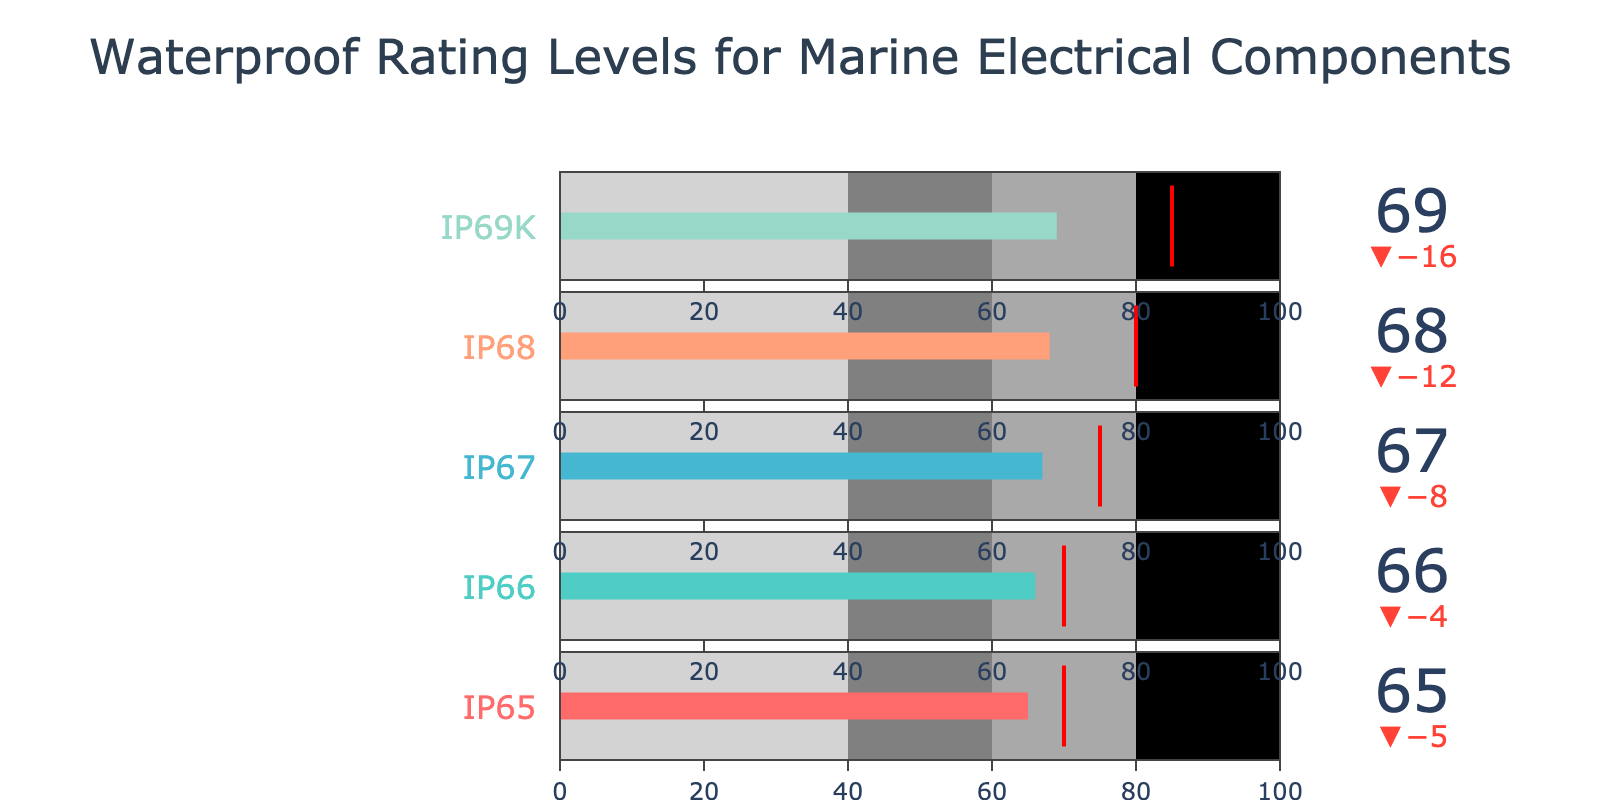What's the title of the figure? The title of the figure is displayed at the top and generally gives an overview of what the visualization is about. Read the text located prominently at the top of the figure.
Answer: Waterproof Rating Levels for Marine Electrical Components How many data points are plotted in the figure? Each bullet chart row represents a data point. You can count the number of different waterproof rating levels provided.
Answer: 5 What is the actual waterproof rating for IP68? Look for the IP68 row and identify the 'Actual' value associated with it.
Answer: 68 Which component has the highest comparative waterproof rating? Compare all 'Comparative' values across the rows and identify the highest value, then see which component it corresponds to.
Answer: IP69K Is the actual waterproof rating for any component below 60? Check the 'Actual' values across all rows to see if any are below 60.
Answer: No Which component has the smallest difference between actual and comparative waterproof ratings? Calculate the difference between ‘Actual’ and ‘Comparative’ for each component and find the smallest difference.
Answer: IP65 What color is used for the IP66 bar in the plot? Identify the bar color for the IP66 row in the figure.
Answer: Light blue What's the average actual waterproof rating of all components? Sum up the 'Actual' values of all components (65 + 66 + 67 + 68 + 69) and divide by the number of components (5).
Answer: 67 In which range does the actual waterproof rating of IP67 fall into? Check the 'Actual' value (67) against the defined ranges (0-40, 40-60, 60-80, 80-100) to determine where it falls.
Answer: 60-80 Explain the bullet chart for IP65 A bullet chart shows an actual value against a comparative value, highlighted with different threshold ranges. For IP65, the actual value is 65, the comparative value is 70, and the ranges are 0-40 (light gray), 40-60 (gray), 60-80 (dark gray), and 80-100 (black).
Answer: The actual value (65) for IP65 is shown against a comparative value (70) within specific ranges 